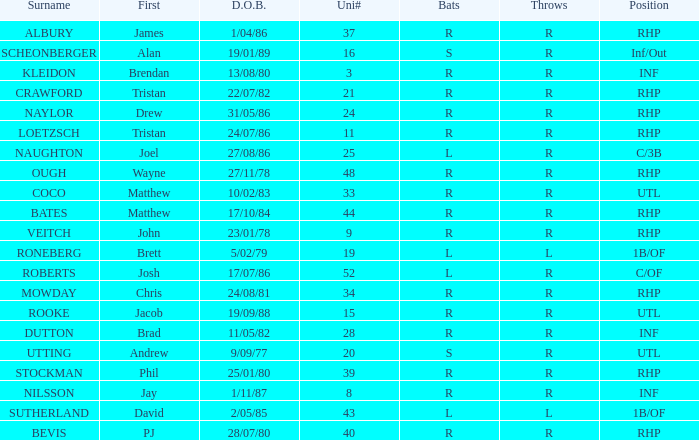Which Surname has Throws of l, and a DOB of 5/02/79? RONEBERG. 